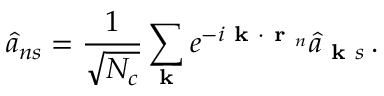Convert formula to latex. <formula><loc_0><loc_0><loc_500><loc_500>\hat { a } _ { n s } = \frac { 1 } { \sqrt { N _ { c } } } \sum _ { k } e ^ { - i k \cdot r _ { n } } \hat { a } _ { k s } \, .</formula> 